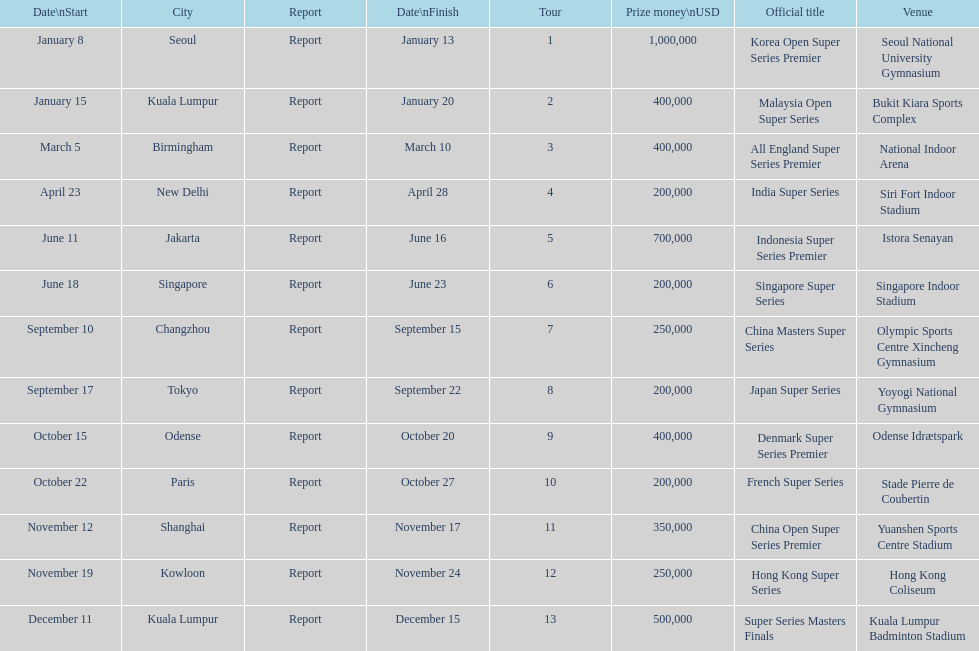Does the malaysia open super series pay more or less than french super series? More. 